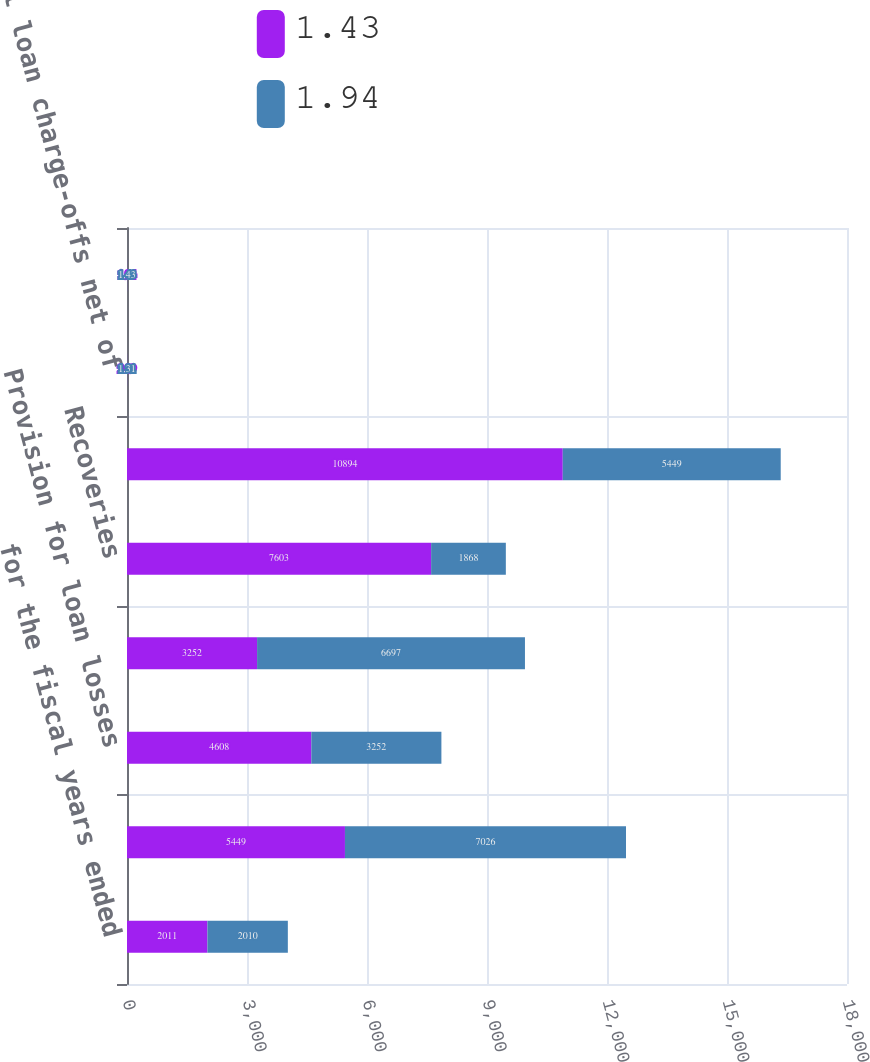Convert chart to OTSL. <chart><loc_0><loc_0><loc_500><loc_500><stacked_bar_chart><ecel><fcel>for the fiscal years ended<fcel>Balance at beginning of year<fcel>Provision for loan losses<fcel>Charge-offs<fcel>Recoveries<fcel>Balance at End of Year<fcel>Total loan charge-offs net of<fcel>Allowance for loan losses as a<nl><fcel>1.43<fcel>2011<fcel>5449<fcel>4608<fcel>3252<fcel>7603<fcel>10894<fcel>2.09<fcel>1.94<nl><fcel>1.94<fcel>2010<fcel>7026<fcel>3252<fcel>6697<fcel>1868<fcel>5449<fcel>1.31<fcel>1.43<nl></chart> 